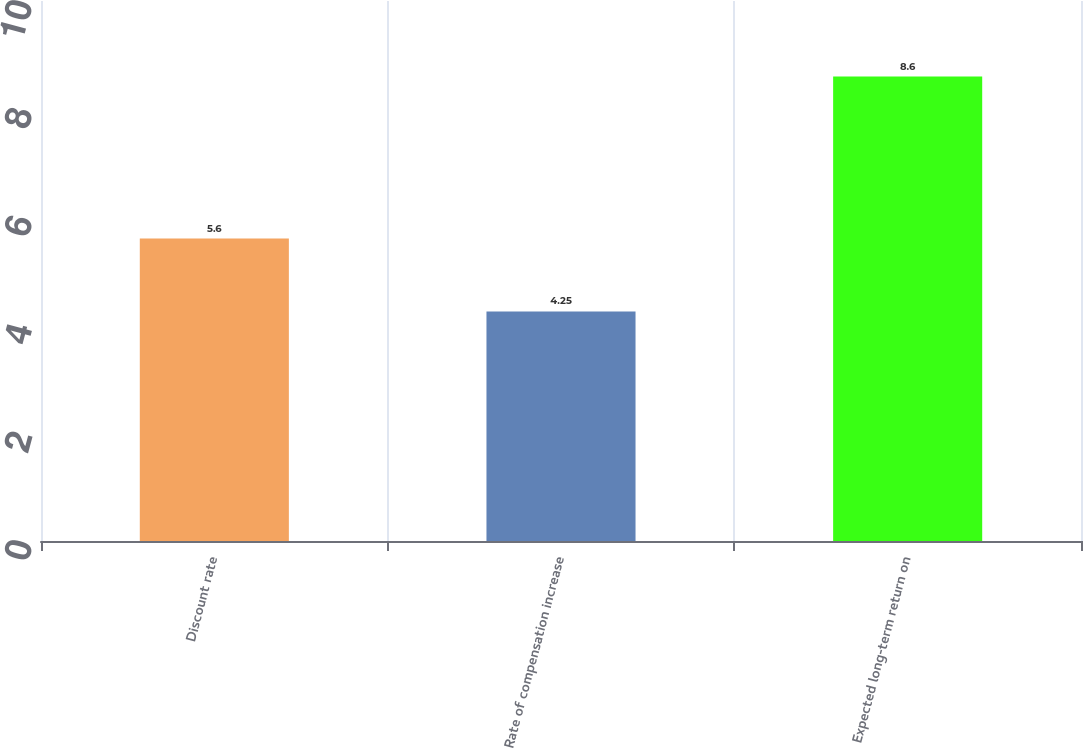Convert chart to OTSL. <chart><loc_0><loc_0><loc_500><loc_500><bar_chart><fcel>Discount rate<fcel>Rate of compensation increase<fcel>Expected long-term return on<nl><fcel>5.6<fcel>4.25<fcel>8.6<nl></chart> 